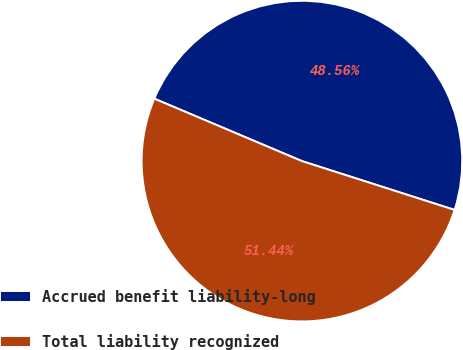Convert chart to OTSL. <chart><loc_0><loc_0><loc_500><loc_500><pie_chart><fcel>Accrued benefit liability-long<fcel>Total liability recognized<nl><fcel>48.56%<fcel>51.44%<nl></chart> 